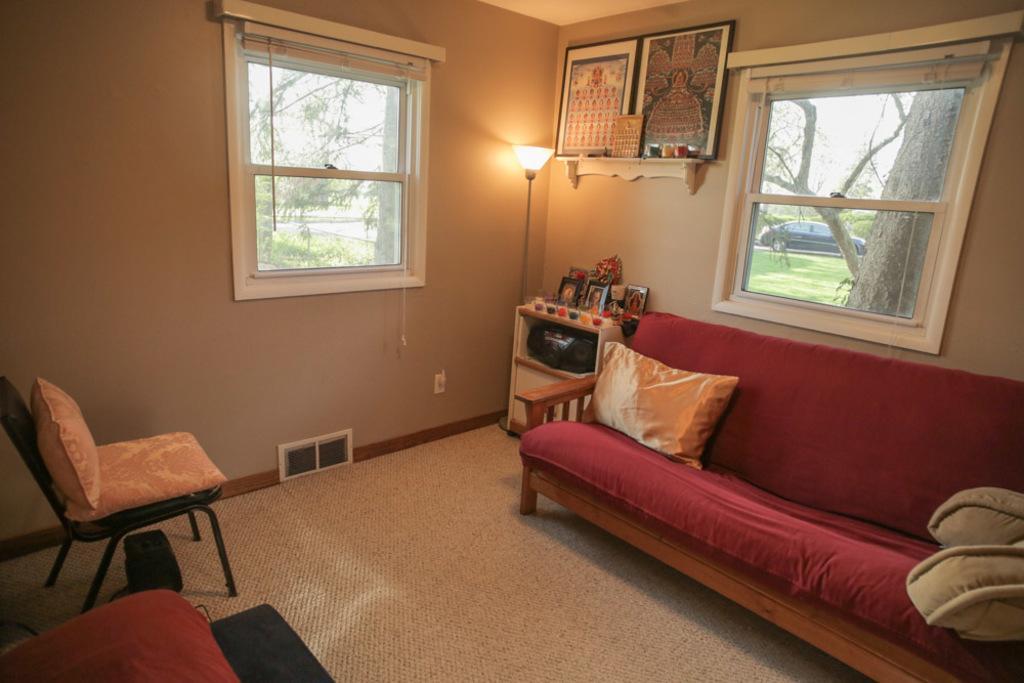In one or two sentences, can you explain what this image depicts? In the picture I can see chairs, red color sofa with pillows on it, I can see a table upon which I can see photo frames are placed, I can see the lamp, photo frames fixed to the wall, I can see glass windows through which I can see trees, a car parked here, I can see grass and the sky in the background. 